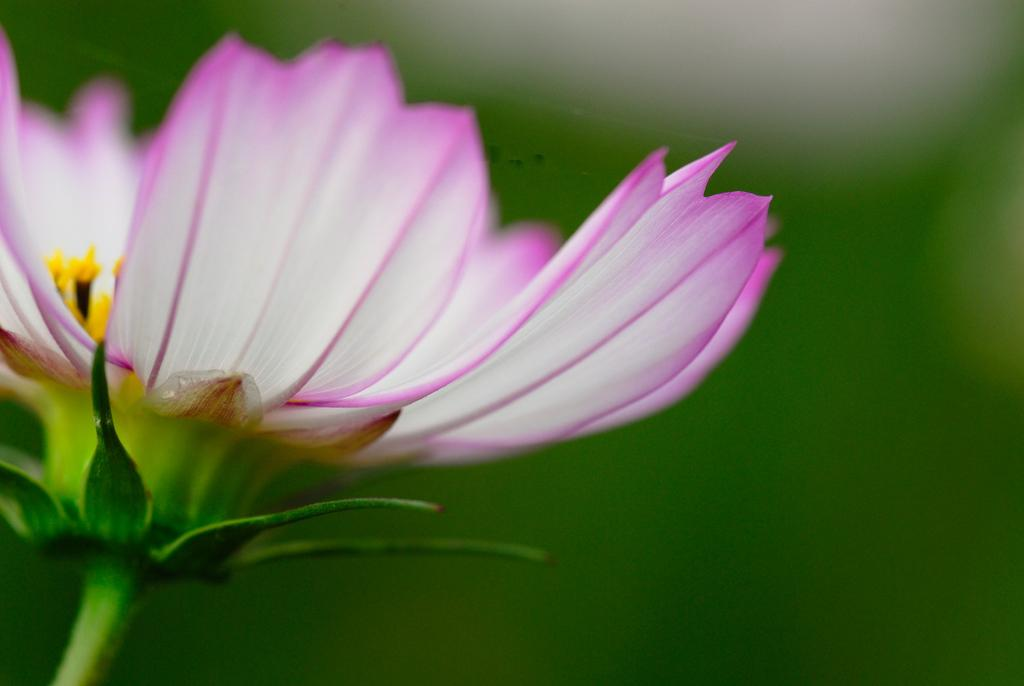What is the main subject of the image? The main subject of the image is a flower. Can you describe the color of the flower? The flower is a combination of pink and white color. What type of square structure can be seen in the background of the image? There is no square structure present in the image; it only features a flower. What observations can be made about the railway system in the image? There is no railway system present in the image; it only features a flower. 